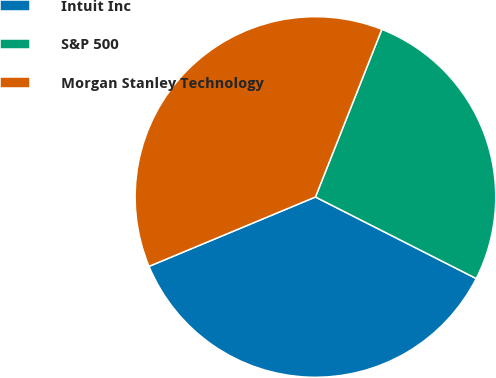<chart> <loc_0><loc_0><loc_500><loc_500><pie_chart><fcel>Intuit Inc<fcel>S&P 500<fcel>Morgan Stanley Technology<nl><fcel>36.24%<fcel>26.47%<fcel>37.29%<nl></chart> 